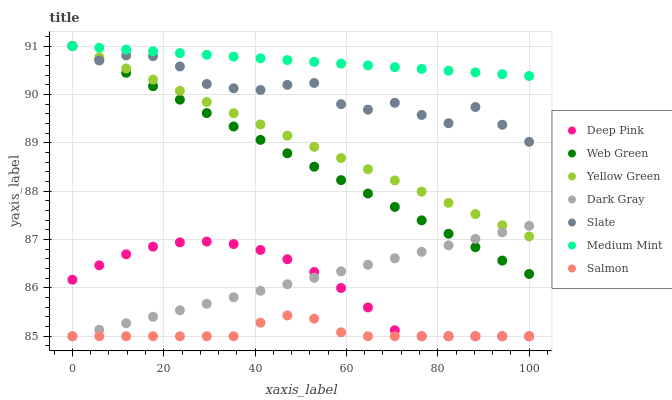Does Salmon have the minimum area under the curve?
Answer yes or no. Yes. Does Medium Mint have the maximum area under the curve?
Answer yes or no. Yes. Does Deep Pink have the minimum area under the curve?
Answer yes or no. No. Does Deep Pink have the maximum area under the curve?
Answer yes or no. No. Is Web Green the smoothest?
Answer yes or no. Yes. Is Slate the roughest?
Answer yes or no. Yes. Is Deep Pink the smoothest?
Answer yes or no. No. Is Deep Pink the roughest?
Answer yes or no. No. Does Deep Pink have the lowest value?
Answer yes or no. Yes. Does Yellow Green have the lowest value?
Answer yes or no. No. Does Web Green have the highest value?
Answer yes or no. Yes. Does Deep Pink have the highest value?
Answer yes or no. No. Is Salmon less than Web Green?
Answer yes or no. Yes. Is Web Green greater than Deep Pink?
Answer yes or no. Yes. Does Medium Mint intersect Yellow Green?
Answer yes or no. Yes. Is Medium Mint less than Yellow Green?
Answer yes or no. No. Is Medium Mint greater than Yellow Green?
Answer yes or no. No. Does Salmon intersect Web Green?
Answer yes or no. No. 